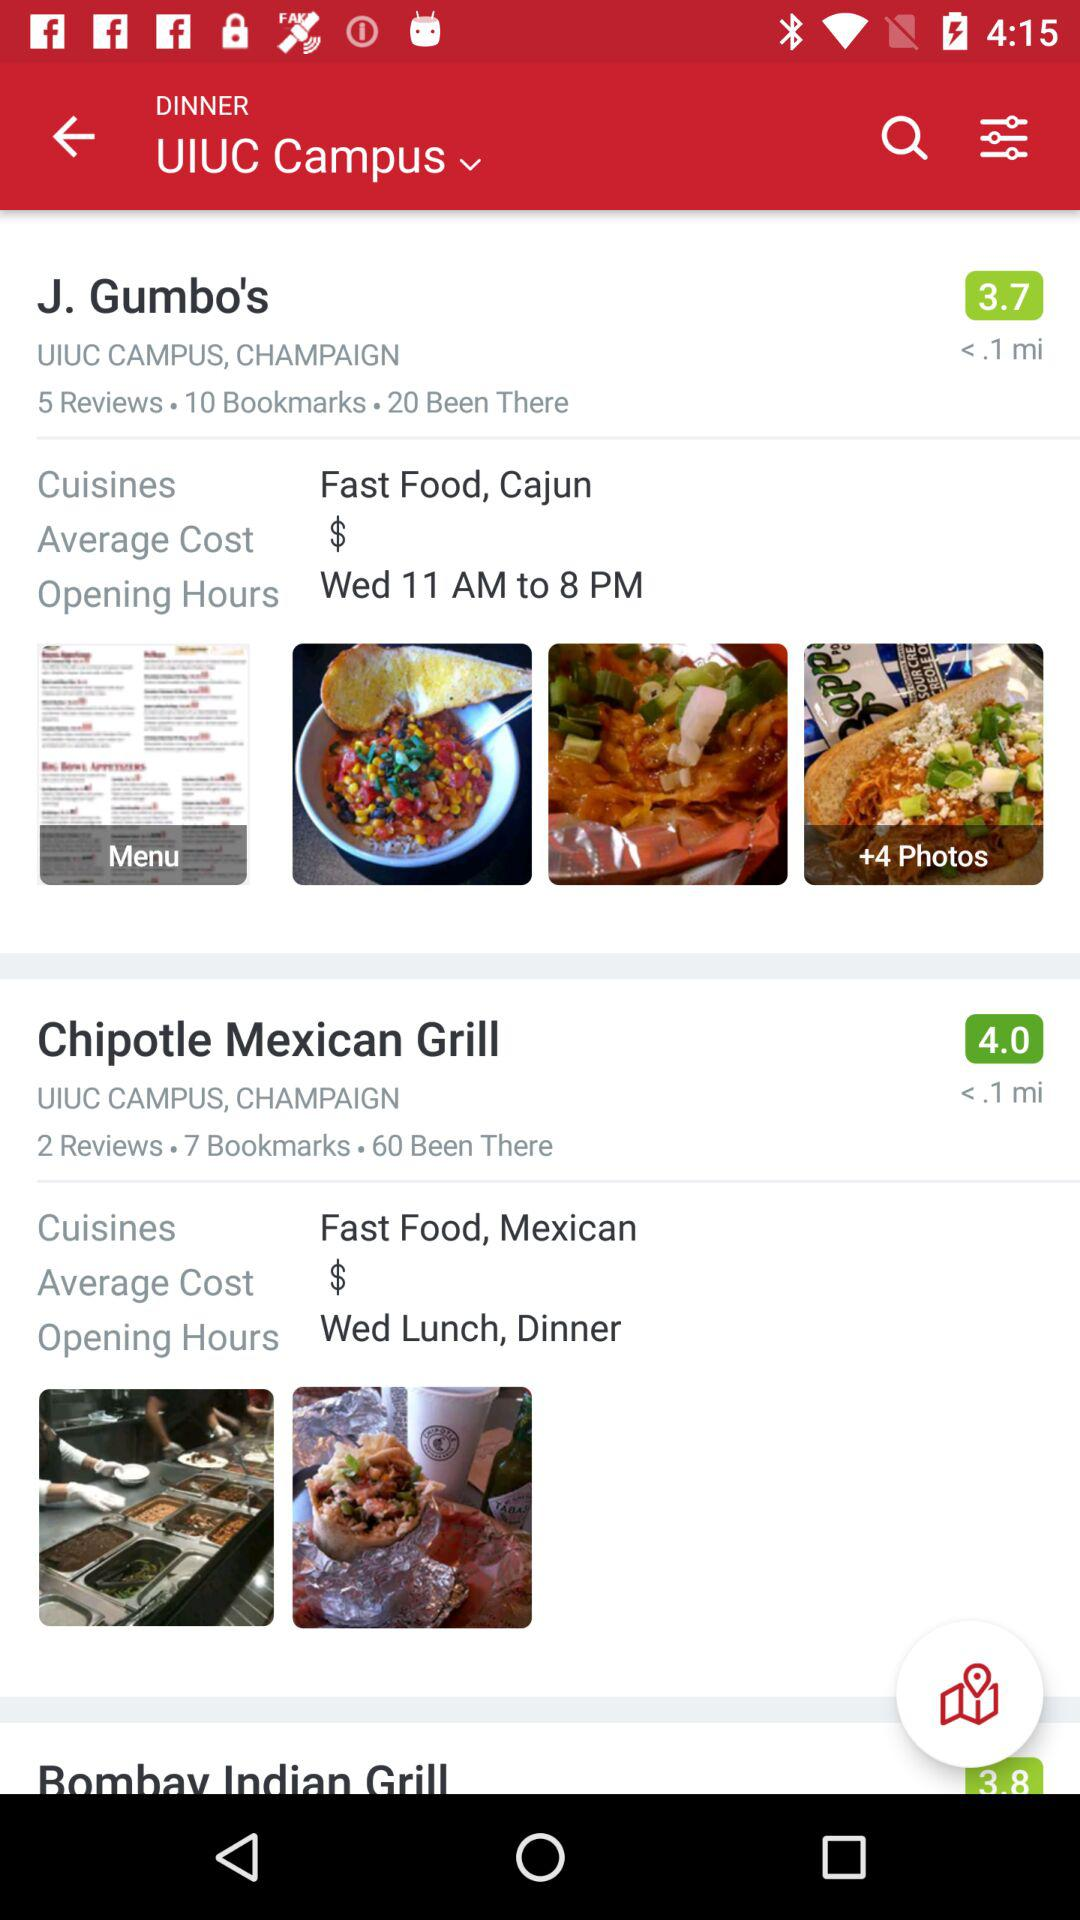How many more reviews does J. Gumbo's have than Chipotle Mexican Grill?
Answer the question using a single word or phrase. 3 